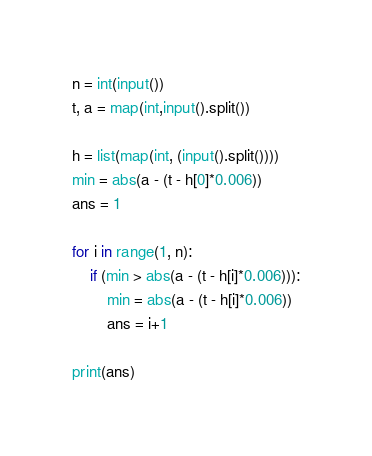<code> <loc_0><loc_0><loc_500><loc_500><_Python_>n = int(input())
t, a = map(int,input().split())

h = list(map(int, (input().split())))
min = abs(a - (t - h[0]*0.006))
ans = 1

for i in range(1, n):
    if (min > abs(a - (t - h[i]*0.006))):
        min = abs(a - (t - h[i]*0.006))
        ans = i+1

print(ans)   </code> 